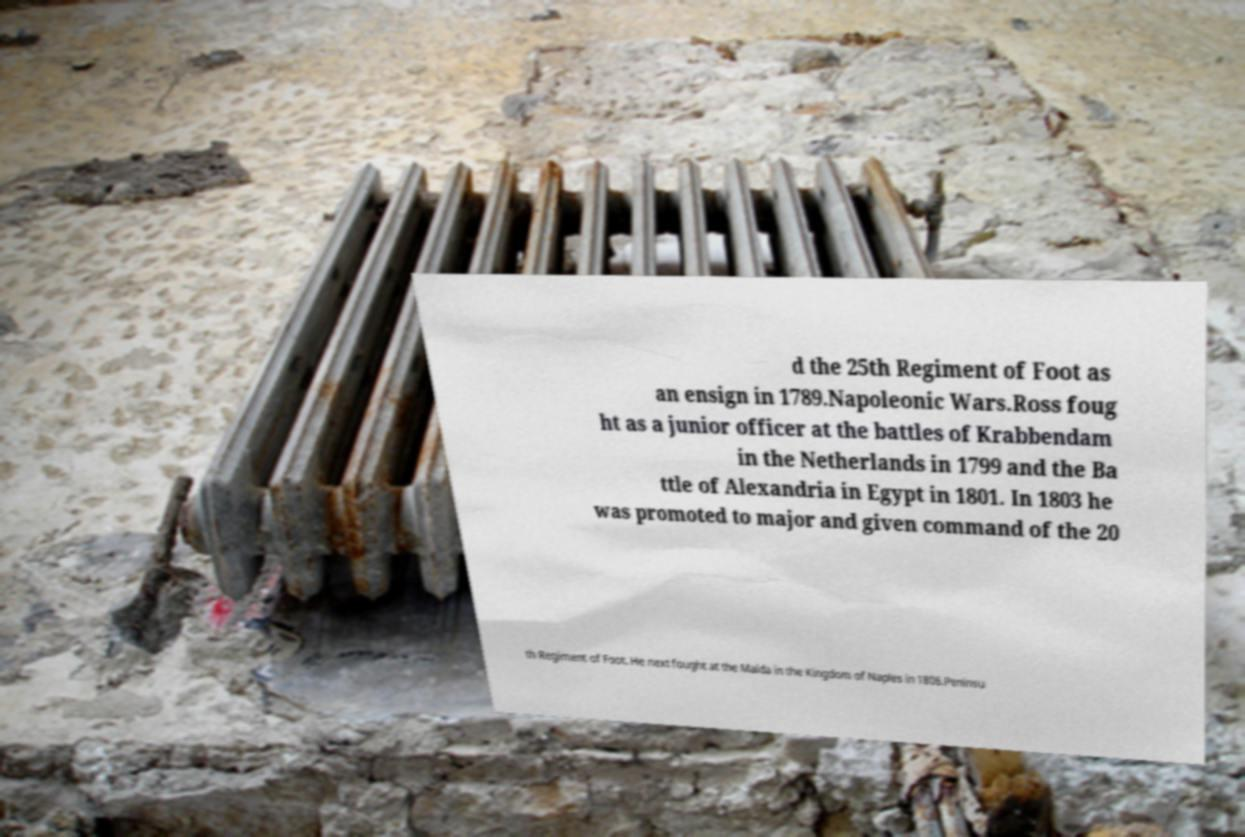There's text embedded in this image that I need extracted. Can you transcribe it verbatim? d the 25th Regiment of Foot as an ensign in 1789.Napoleonic Wars.Ross foug ht as a junior officer at the battles of Krabbendam in the Netherlands in 1799 and the Ba ttle of Alexandria in Egypt in 1801. In 1803 he was promoted to major and given command of the 20 th Regiment of Foot. He next fought at the Maida in the Kingdom of Naples in 1806.Peninsu 